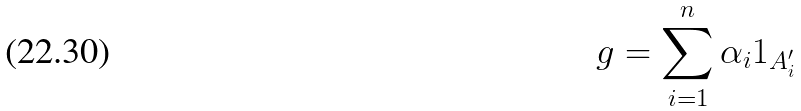<formula> <loc_0><loc_0><loc_500><loc_500>g = \sum _ { i = 1 } ^ { n } \alpha _ { i } 1 _ { A _ { i } ^ { \prime } }</formula> 